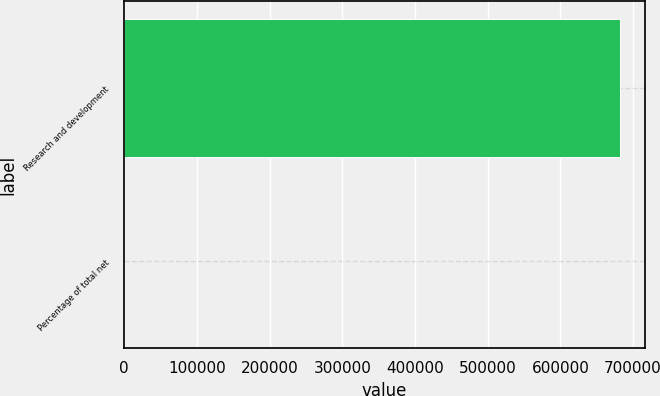Convert chart. <chart><loc_0><loc_0><loc_500><loc_500><bar_chart><fcel>Research and development<fcel>Percentage of total net<nl><fcel>682125<fcel>16<nl></chart> 